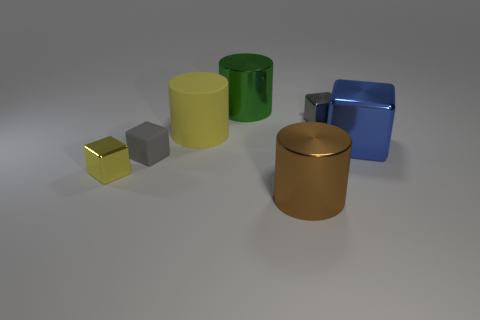What materials do these objects appear to be made of? The objects appear to have various finishes: the yellow and grey ones look metallic, while the green and blue have a matte appearance, possibly plastic. The golden object looks to have a brushed metallic surface. 